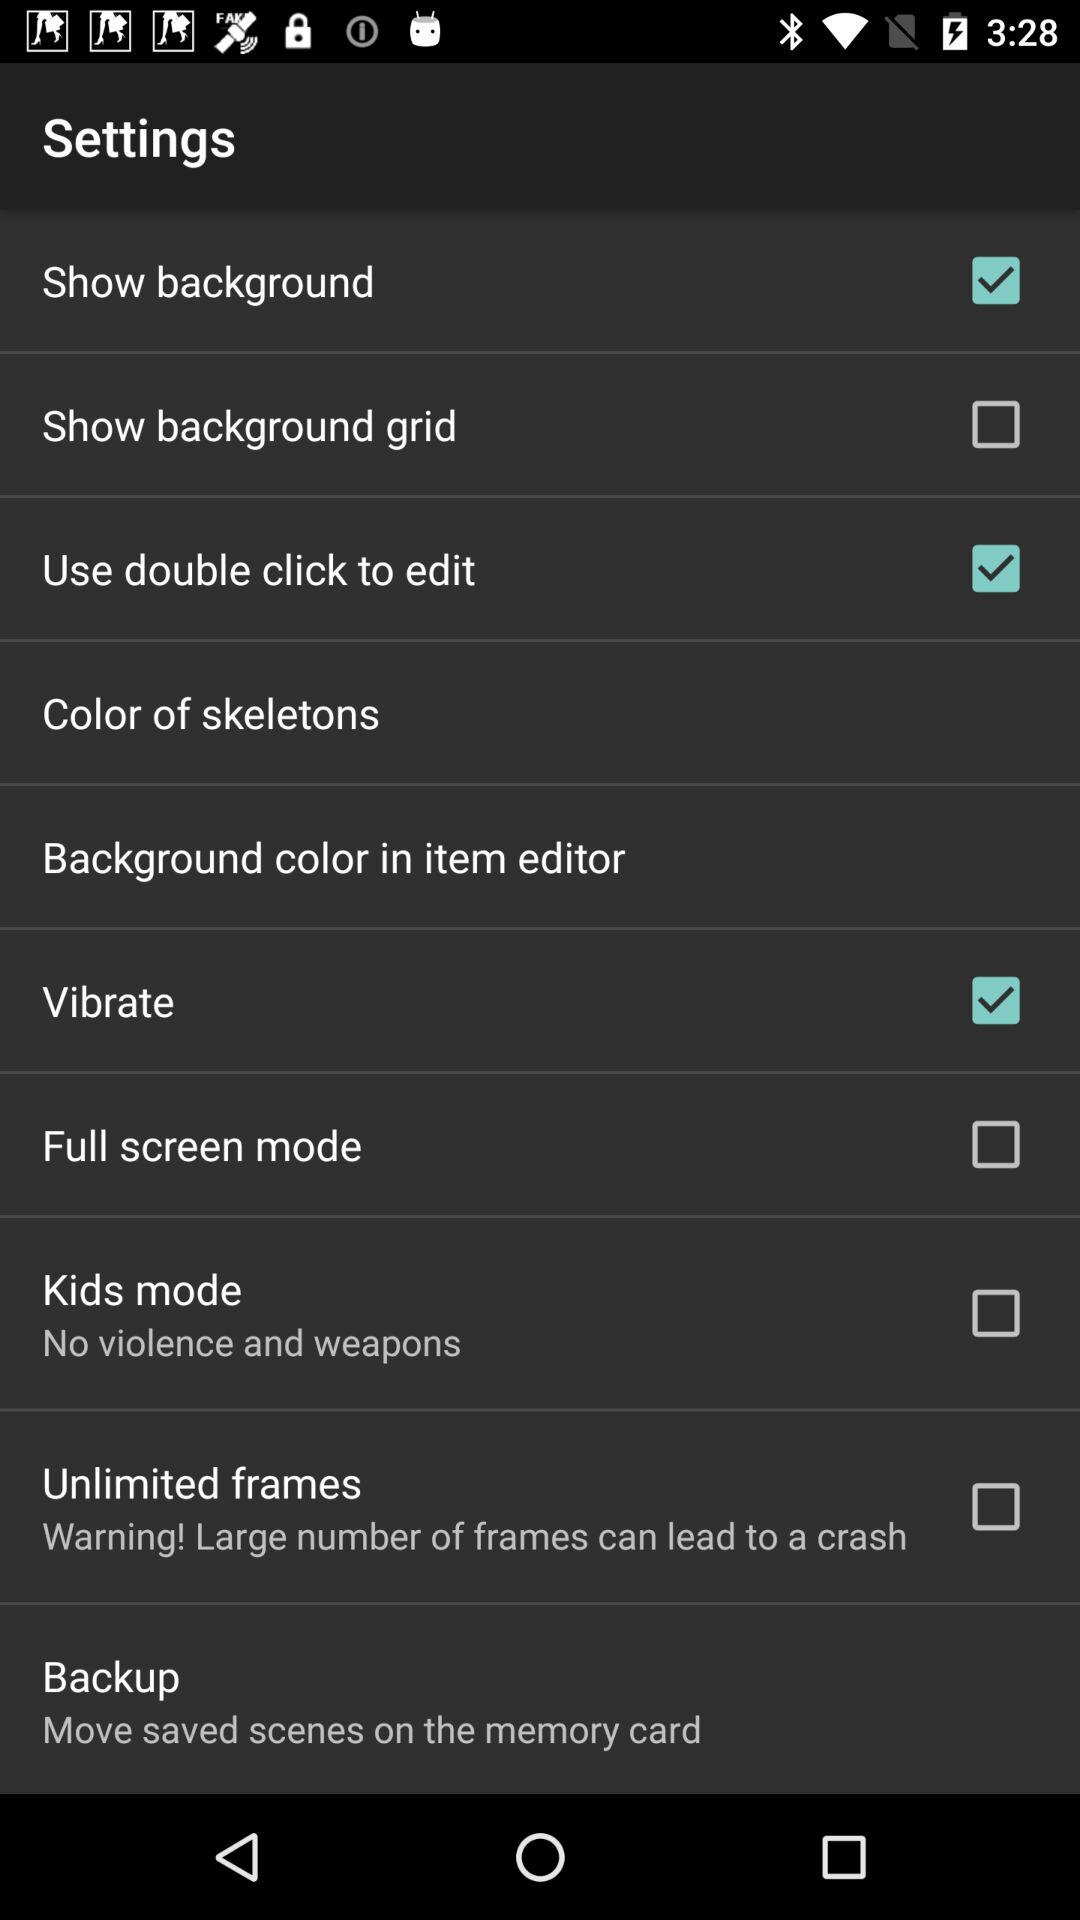What is the setting for "Kids mode"? The setting for "Kids mode" is off. 